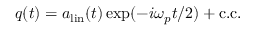Convert formula to latex. <formula><loc_0><loc_0><loc_500><loc_500>q ( t ) = a _ { l i n } ( t ) \exp ( - i \omega _ { p } t / 2 ) + c . c .</formula> 